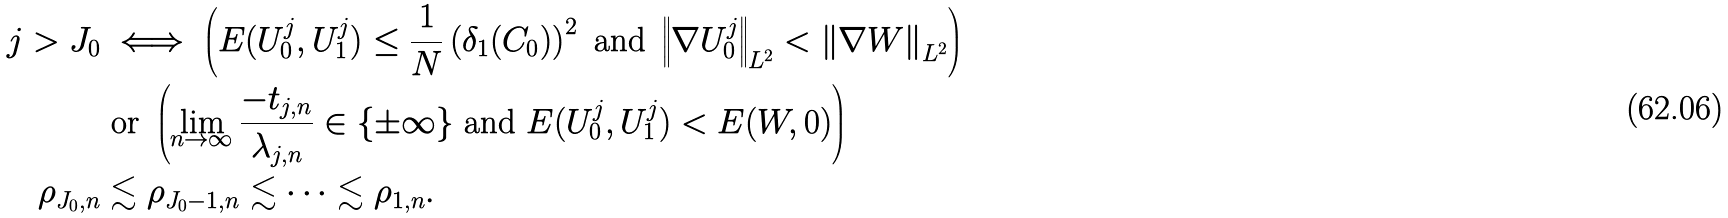Convert formula to latex. <formula><loc_0><loc_0><loc_500><loc_500>j > J _ { 0 } & \iff \left ( E ( U ^ { j } _ { 0 } , U ^ { j } _ { 1 } ) \leq \frac { 1 } { N } \left ( \delta _ { 1 } ( C _ { 0 } ) \right ) ^ { 2 } \text { and } \left \| \nabla U _ { 0 } ^ { j } \right \| _ { L ^ { 2 } } < \left \| \nabla W \right \| _ { L ^ { 2 } } \right ) \\ & \text { or } \left ( \lim _ { n \to \infty } \frac { - t _ { j , n } } { \lambda _ { j , n } } \in \{ \pm \infty \} \text { and } E ( U ^ { j } _ { 0 } , U ^ { j } _ { 1 } ) < E ( W , 0 ) \right ) \\ \rho _ { J _ { 0 } , n } & \lesssim \rho _ { J _ { 0 } - 1 , n } \lesssim \dots \lesssim \rho _ { 1 , n } .</formula> 